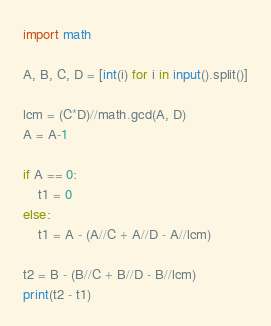Convert code to text. <code><loc_0><loc_0><loc_500><loc_500><_Python_>import math

A, B, C, D = [int(i) for i in input().split()]

lcm = (C*D)//math.gcd(A, D)
A = A-1

if A == 0:
	t1 = 0
else:
	t1 = A - (A//C + A//D - A//lcm)

t2 = B - (B//C + B//D - B//lcm)
print(t2 - t1)
</code> 